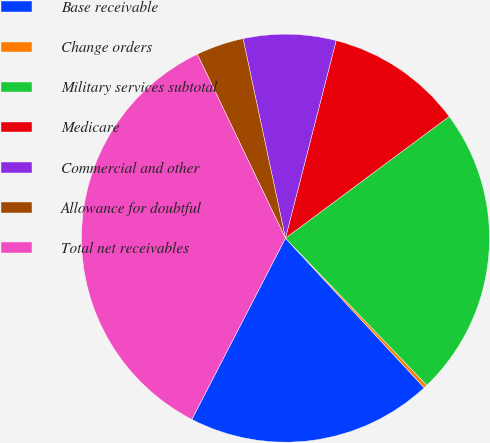<chart> <loc_0><loc_0><loc_500><loc_500><pie_chart><fcel>Base receivable<fcel>Change orders<fcel>Military services subtotal<fcel>Medicare<fcel>Commercial and other<fcel>Allowance for doubtful<fcel>Total net receivables<nl><fcel>19.49%<fcel>0.28%<fcel>22.99%<fcel>10.83%<fcel>7.33%<fcel>3.78%<fcel>35.3%<nl></chart> 